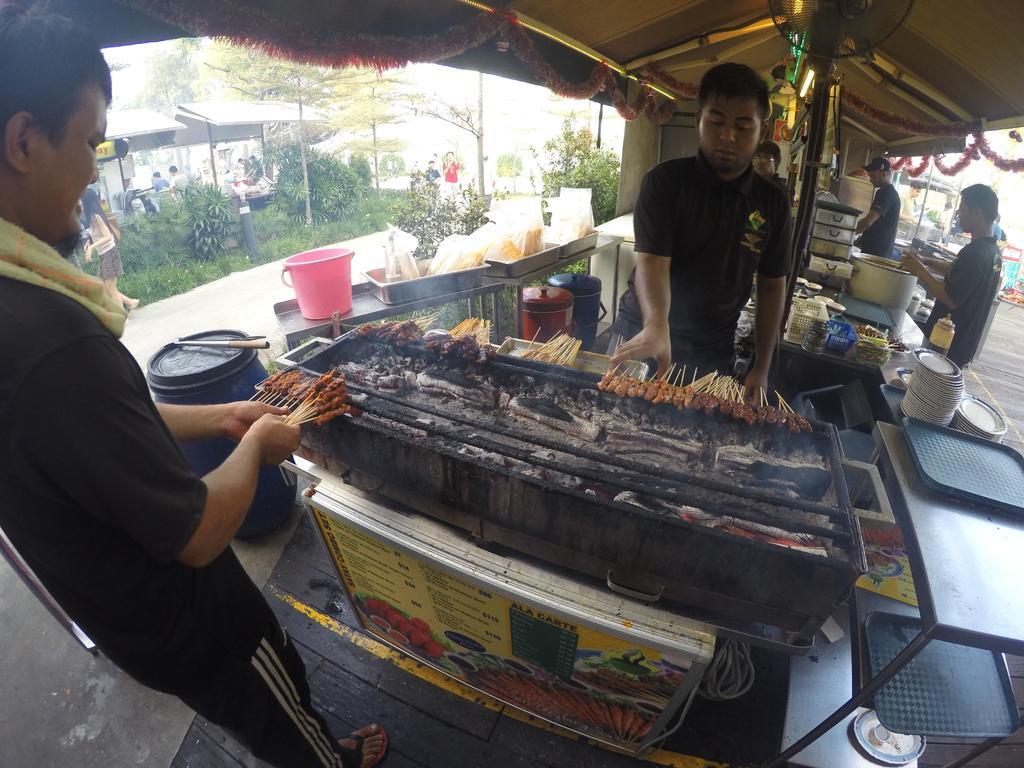In one or two sentences, can you explain what this image depicts? There are few people standing. I can see trays, plates, bowls, utensils and few other things are placed on the table. This looks like a stove. These are the food items, which are being cooked. This looks like a menu board. I can see a barrel, which is closed with a lid. This looks like a bucket and the trays, which are placed on the other table. These are the trees and bushes. I can see few people sitting. This looks like a tent. 